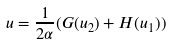<formula> <loc_0><loc_0><loc_500><loc_500>u = \frac { 1 } { 2 \alpha } ( G ( u _ { 2 } ) + H ( u _ { 1 } ) )</formula> 